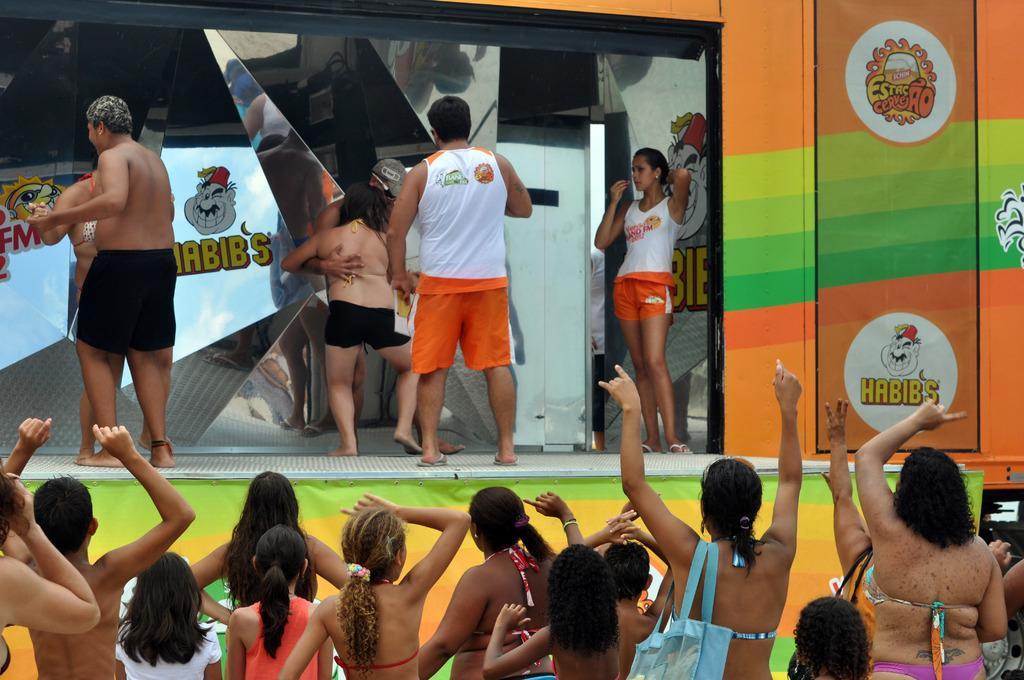Who or what can be seen in the image? There are people in the image. What is the main feature of the setting? There is a stage in the image. What objects are present that can create reflections? There are mirrors in the image. What can be observed as a result of the mirrors? Reflections are visible in the image. What type of signage is present in the image? There is a poster in the image. What can be read or understood from the image? There is information present in the image. What other type of signage is present in the image? There is a hoarding in the image. What type of error can be seen in the image? There is no error present in the image. What kind of jar is visible on the stage in the image? There is no jar present in the image. 